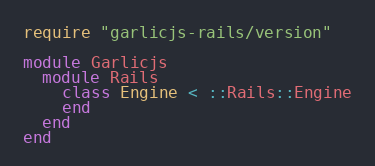Convert code to text. <code><loc_0><loc_0><loc_500><loc_500><_Ruby_>require "garlicjs-rails/version"

module Garlicjs
  module Rails
    class Engine < ::Rails::Engine
    end
  end
end
</code> 